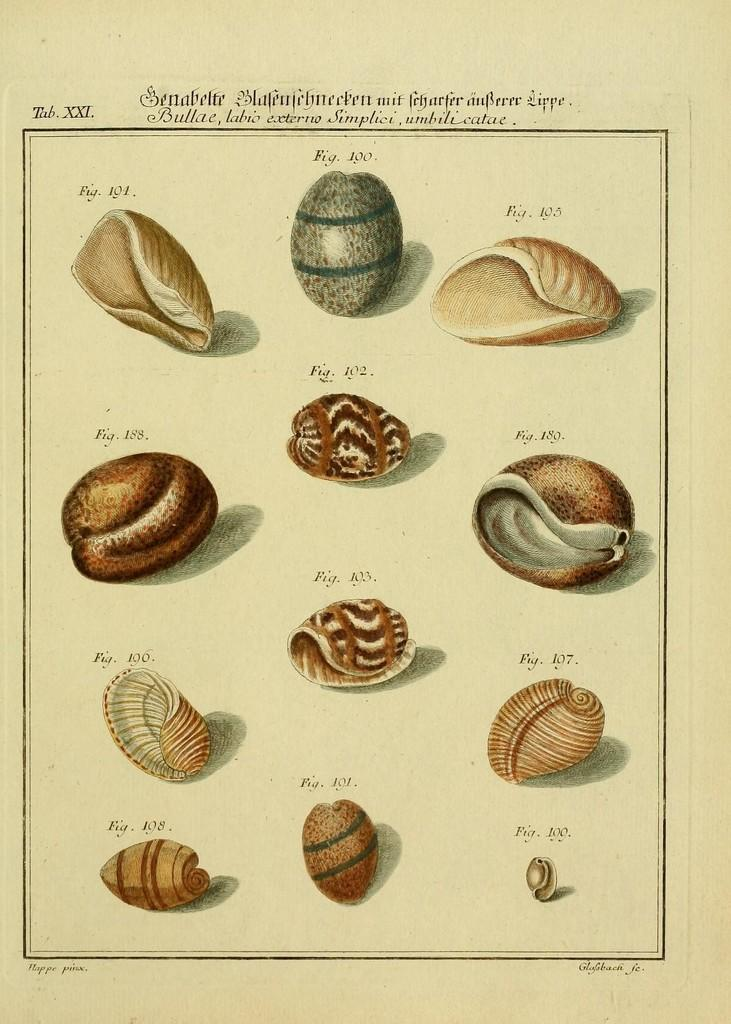What is depicted on the white paper in the image? There are images of different types of shells on a white paper. What else can be seen in the image besides the shells? There is text at the top of the image. What type of wire is being used to conduct a science experiment in the image? There is no wire or science experiment present in the image; it only features images of shells and text. 